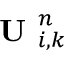<formula> <loc_0><loc_0><loc_500><loc_500>U _ { i , k } ^ { n }</formula> 